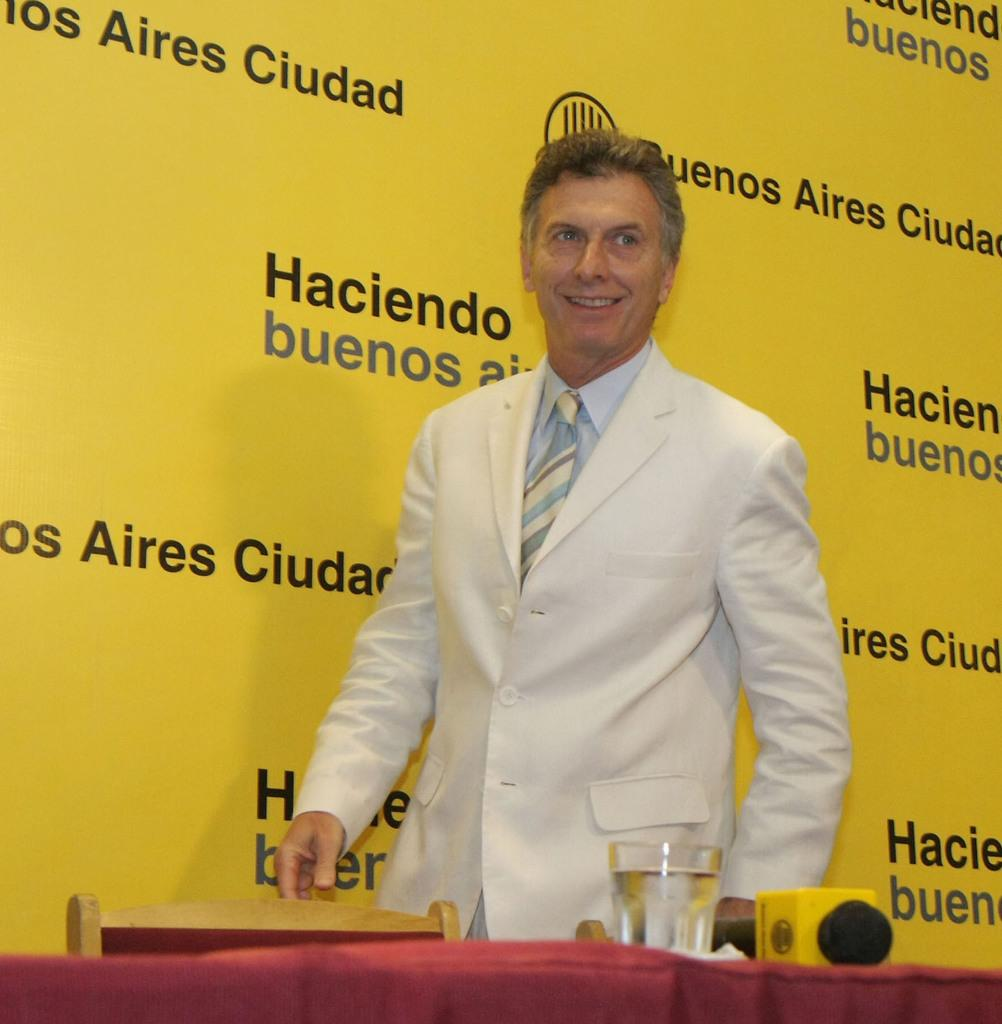What is the man in the image doing? The man is standing and smiling in the image. What object can be used for sitting in the image? There is a chair in the image. What beverage is visible in the image? There is a glass of water in the image. What object is typically used for amplifying sound in the image? There is a microphone (mike) in the image. What item might be used for wiping or blowing one's nose in the image? There is a tissue on the table in the image. What can be seen in the background of the image? There is a board in the background of the image. What type of airplane is flying in the image? There is no airplane present in the image. In which direction is the man facing in the image? The provided facts do not specify the direction the man is facing. 